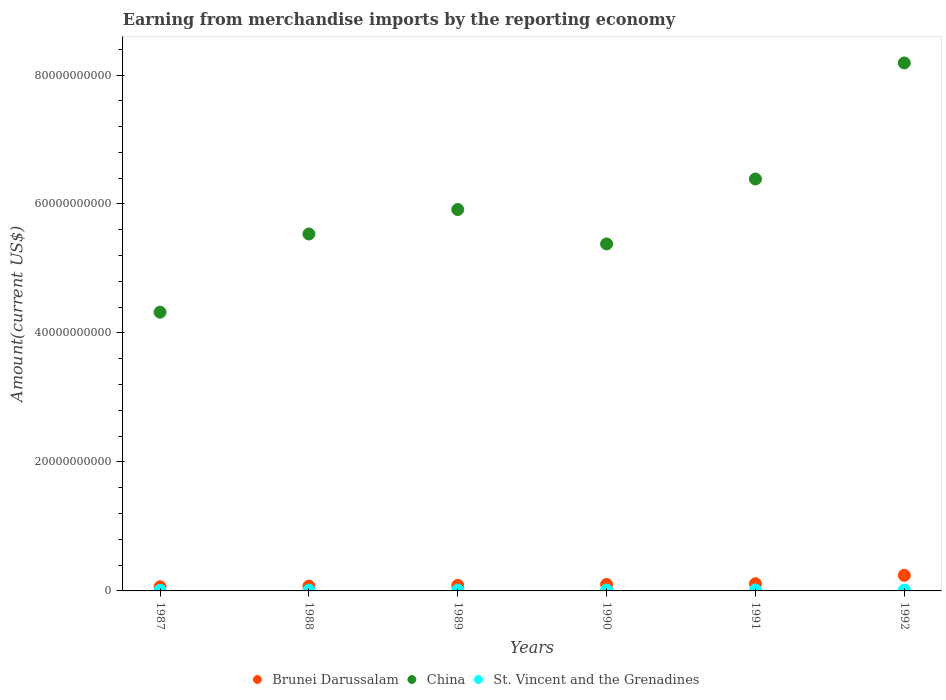Is the number of dotlines equal to the number of legend labels?
Provide a succinct answer. Yes. What is the amount earned from merchandise imports in St. Vincent and the Grenadines in 1990?
Offer a very short reply. 1.36e+08. Across all years, what is the maximum amount earned from merchandise imports in China?
Keep it short and to the point. 8.19e+1. Across all years, what is the minimum amount earned from merchandise imports in China?
Keep it short and to the point. 4.32e+1. In which year was the amount earned from merchandise imports in St. Vincent and the Grenadines minimum?
Offer a terse response. 1987. What is the total amount earned from merchandise imports in Brunei Darussalam in the graph?
Give a very brief answer. 6.77e+09. What is the difference between the amount earned from merchandise imports in St. Vincent and the Grenadines in 1988 and that in 1992?
Your answer should be compact. -2.31e+06. What is the difference between the amount earned from merchandise imports in Brunei Darussalam in 1992 and the amount earned from merchandise imports in China in 1989?
Provide a succinct answer. -5.67e+1. What is the average amount earned from merchandise imports in China per year?
Ensure brevity in your answer.  5.95e+1. In the year 1991, what is the difference between the amount earned from merchandise imports in St. Vincent and the Grenadines and amount earned from merchandise imports in China?
Make the answer very short. -6.37e+1. In how many years, is the amount earned from merchandise imports in Brunei Darussalam greater than 48000000000 US$?
Offer a very short reply. 0. What is the ratio of the amount earned from merchandise imports in St. Vincent and the Grenadines in 1990 to that in 1991?
Ensure brevity in your answer.  0.97. What is the difference between the highest and the second highest amount earned from merchandise imports in China?
Make the answer very short. 1.80e+1. What is the difference between the highest and the lowest amount earned from merchandise imports in St. Vincent and the Grenadines?
Your response must be concise. 4.17e+07. In how many years, is the amount earned from merchandise imports in St. Vincent and the Grenadines greater than the average amount earned from merchandise imports in St. Vincent and the Grenadines taken over all years?
Provide a succinct answer. 3. Is the sum of the amount earned from merchandise imports in China in 1987 and 1988 greater than the maximum amount earned from merchandise imports in St. Vincent and the Grenadines across all years?
Provide a short and direct response. Yes. Is the amount earned from merchandise imports in Brunei Darussalam strictly greater than the amount earned from merchandise imports in St. Vincent and the Grenadines over the years?
Keep it short and to the point. Yes. Is the amount earned from merchandise imports in Brunei Darussalam strictly less than the amount earned from merchandise imports in China over the years?
Your answer should be compact. Yes. Are the values on the major ticks of Y-axis written in scientific E-notation?
Offer a terse response. No. Does the graph contain any zero values?
Your answer should be compact. No. Does the graph contain grids?
Offer a terse response. No. Where does the legend appear in the graph?
Keep it short and to the point. Bottom center. What is the title of the graph?
Give a very brief answer. Earning from merchandise imports by the reporting economy. What is the label or title of the X-axis?
Provide a succinct answer. Years. What is the label or title of the Y-axis?
Offer a terse response. Amount(current US$). What is the Amount(current US$) in Brunei Darussalam in 1987?
Ensure brevity in your answer.  6.41e+08. What is the Amount(current US$) in China in 1987?
Give a very brief answer. 4.32e+1. What is the Amount(current US$) in St. Vincent and the Grenadines in 1987?
Your response must be concise. 9.80e+07. What is the Amount(current US$) of Brunei Darussalam in 1988?
Your response must be concise. 7.44e+08. What is the Amount(current US$) of China in 1988?
Offer a very short reply. 5.54e+1. What is the Amount(current US$) in St. Vincent and the Grenadines in 1988?
Give a very brief answer. 1.22e+08. What is the Amount(current US$) in Brunei Darussalam in 1989?
Offer a very short reply. 8.59e+08. What is the Amount(current US$) of China in 1989?
Provide a short and direct response. 5.91e+1. What is the Amount(current US$) in St. Vincent and the Grenadines in 1989?
Give a very brief answer. 1.27e+08. What is the Amount(current US$) of Brunei Darussalam in 1990?
Offer a terse response. 1.00e+09. What is the Amount(current US$) of China in 1990?
Provide a short and direct response. 5.38e+1. What is the Amount(current US$) of St. Vincent and the Grenadines in 1990?
Ensure brevity in your answer.  1.36e+08. What is the Amount(current US$) in Brunei Darussalam in 1991?
Make the answer very short. 1.11e+09. What is the Amount(current US$) of China in 1991?
Keep it short and to the point. 6.39e+1. What is the Amount(current US$) in St. Vincent and the Grenadines in 1991?
Give a very brief answer. 1.40e+08. What is the Amount(current US$) in Brunei Darussalam in 1992?
Keep it short and to the point. 2.42e+09. What is the Amount(current US$) of China in 1992?
Your answer should be compact. 8.19e+1. What is the Amount(current US$) in St. Vincent and the Grenadines in 1992?
Offer a very short reply. 1.25e+08. Across all years, what is the maximum Amount(current US$) in Brunei Darussalam?
Keep it short and to the point. 2.42e+09. Across all years, what is the maximum Amount(current US$) of China?
Provide a succinct answer. 8.19e+1. Across all years, what is the maximum Amount(current US$) of St. Vincent and the Grenadines?
Provide a short and direct response. 1.40e+08. Across all years, what is the minimum Amount(current US$) in Brunei Darussalam?
Keep it short and to the point. 6.41e+08. Across all years, what is the minimum Amount(current US$) of China?
Keep it short and to the point. 4.32e+1. Across all years, what is the minimum Amount(current US$) in St. Vincent and the Grenadines?
Provide a short and direct response. 9.80e+07. What is the total Amount(current US$) in Brunei Darussalam in the graph?
Ensure brevity in your answer.  6.77e+09. What is the total Amount(current US$) in China in the graph?
Offer a very short reply. 3.57e+11. What is the total Amount(current US$) in St. Vincent and the Grenadines in the graph?
Provide a succinct answer. 7.48e+08. What is the difference between the Amount(current US$) of Brunei Darussalam in 1987 and that in 1988?
Ensure brevity in your answer.  -1.03e+08. What is the difference between the Amount(current US$) of China in 1987 and that in 1988?
Make the answer very short. -1.21e+1. What is the difference between the Amount(current US$) of St. Vincent and the Grenadines in 1987 and that in 1988?
Provide a short and direct response. -2.43e+07. What is the difference between the Amount(current US$) of Brunei Darussalam in 1987 and that in 1989?
Make the answer very short. -2.18e+08. What is the difference between the Amount(current US$) in China in 1987 and that in 1989?
Ensure brevity in your answer.  -1.59e+1. What is the difference between the Amount(current US$) in St. Vincent and the Grenadines in 1987 and that in 1989?
Provide a succinct answer. -2.95e+07. What is the difference between the Amount(current US$) of Brunei Darussalam in 1987 and that in 1990?
Your answer should be very brief. -3.59e+08. What is the difference between the Amount(current US$) in China in 1987 and that in 1990?
Make the answer very short. -1.06e+1. What is the difference between the Amount(current US$) of St. Vincent and the Grenadines in 1987 and that in 1990?
Provide a short and direct response. -3.80e+07. What is the difference between the Amount(current US$) of Brunei Darussalam in 1987 and that in 1991?
Provide a short and direct response. -4.70e+08. What is the difference between the Amount(current US$) of China in 1987 and that in 1991?
Offer a terse response. -2.07e+1. What is the difference between the Amount(current US$) of St. Vincent and the Grenadines in 1987 and that in 1991?
Provide a short and direct response. -4.17e+07. What is the difference between the Amount(current US$) of Brunei Darussalam in 1987 and that in 1992?
Your answer should be compact. -1.78e+09. What is the difference between the Amount(current US$) in China in 1987 and that in 1992?
Your response must be concise. -3.86e+1. What is the difference between the Amount(current US$) in St. Vincent and the Grenadines in 1987 and that in 1992?
Offer a terse response. -2.66e+07. What is the difference between the Amount(current US$) in Brunei Darussalam in 1988 and that in 1989?
Your answer should be compact. -1.15e+08. What is the difference between the Amount(current US$) of China in 1988 and that in 1989?
Provide a succinct answer. -3.79e+09. What is the difference between the Amount(current US$) in St. Vincent and the Grenadines in 1988 and that in 1989?
Provide a succinct answer. -5.23e+06. What is the difference between the Amount(current US$) of Brunei Darussalam in 1988 and that in 1990?
Your response must be concise. -2.57e+08. What is the difference between the Amount(current US$) of China in 1988 and that in 1990?
Make the answer very short. 1.54e+09. What is the difference between the Amount(current US$) of St. Vincent and the Grenadines in 1988 and that in 1990?
Keep it short and to the point. -1.37e+07. What is the difference between the Amount(current US$) in Brunei Darussalam in 1988 and that in 1991?
Provide a succinct answer. -3.67e+08. What is the difference between the Amount(current US$) of China in 1988 and that in 1991?
Keep it short and to the point. -8.52e+09. What is the difference between the Amount(current US$) of St. Vincent and the Grenadines in 1988 and that in 1991?
Make the answer very short. -1.74e+07. What is the difference between the Amount(current US$) of Brunei Darussalam in 1988 and that in 1992?
Make the answer very short. -1.67e+09. What is the difference between the Amount(current US$) in China in 1988 and that in 1992?
Your answer should be compact. -2.65e+1. What is the difference between the Amount(current US$) of St. Vincent and the Grenadines in 1988 and that in 1992?
Provide a short and direct response. -2.31e+06. What is the difference between the Amount(current US$) of Brunei Darussalam in 1989 and that in 1990?
Give a very brief answer. -1.42e+08. What is the difference between the Amount(current US$) in China in 1989 and that in 1990?
Provide a short and direct response. 5.33e+09. What is the difference between the Amount(current US$) in St. Vincent and the Grenadines in 1989 and that in 1990?
Offer a terse response. -8.48e+06. What is the difference between the Amount(current US$) of Brunei Darussalam in 1989 and that in 1991?
Keep it short and to the point. -2.52e+08. What is the difference between the Amount(current US$) in China in 1989 and that in 1991?
Provide a short and direct response. -4.74e+09. What is the difference between the Amount(current US$) of St. Vincent and the Grenadines in 1989 and that in 1991?
Give a very brief answer. -1.22e+07. What is the difference between the Amount(current US$) in Brunei Darussalam in 1989 and that in 1992?
Keep it short and to the point. -1.56e+09. What is the difference between the Amount(current US$) of China in 1989 and that in 1992?
Keep it short and to the point. -2.27e+1. What is the difference between the Amount(current US$) in St. Vincent and the Grenadines in 1989 and that in 1992?
Your answer should be very brief. 2.92e+06. What is the difference between the Amount(current US$) in Brunei Darussalam in 1990 and that in 1991?
Your answer should be very brief. -1.11e+08. What is the difference between the Amount(current US$) in China in 1990 and that in 1991?
Your answer should be compact. -1.01e+1. What is the difference between the Amount(current US$) of St. Vincent and the Grenadines in 1990 and that in 1991?
Ensure brevity in your answer.  -3.73e+06. What is the difference between the Amount(current US$) in Brunei Darussalam in 1990 and that in 1992?
Your answer should be compact. -1.42e+09. What is the difference between the Amount(current US$) in China in 1990 and that in 1992?
Offer a very short reply. -2.81e+1. What is the difference between the Amount(current US$) in St. Vincent and the Grenadines in 1990 and that in 1992?
Provide a short and direct response. 1.14e+07. What is the difference between the Amount(current US$) in Brunei Darussalam in 1991 and that in 1992?
Ensure brevity in your answer.  -1.31e+09. What is the difference between the Amount(current US$) of China in 1991 and that in 1992?
Provide a succinct answer. -1.80e+1. What is the difference between the Amount(current US$) in St. Vincent and the Grenadines in 1991 and that in 1992?
Provide a short and direct response. 1.51e+07. What is the difference between the Amount(current US$) of Brunei Darussalam in 1987 and the Amount(current US$) of China in 1988?
Make the answer very short. -5.47e+1. What is the difference between the Amount(current US$) of Brunei Darussalam in 1987 and the Amount(current US$) of St. Vincent and the Grenadines in 1988?
Provide a succinct answer. 5.18e+08. What is the difference between the Amount(current US$) of China in 1987 and the Amount(current US$) of St. Vincent and the Grenadines in 1988?
Your answer should be compact. 4.31e+1. What is the difference between the Amount(current US$) of Brunei Darussalam in 1987 and the Amount(current US$) of China in 1989?
Your response must be concise. -5.85e+1. What is the difference between the Amount(current US$) in Brunei Darussalam in 1987 and the Amount(current US$) in St. Vincent and the Grenadines in 1989?
Your answer should be compact. 5.13e+08. What is the difference between the Amount(current US$) of China in 1987 and the Amount(current US$) of St. Vincent and the Grenadines in 1989?
Provide a short and direct response. 4.31e+1. What is the difference between the Amount(current US$) of Brunei Darussalam in 1987 and the Amount(current US$) of China in 1990?
Offer a terse response. -5.32e+1. What is the difference between the Amount(current US$) in Brunei Darussalam in 1987 and the Amount(current US$) in St. Vincent and the Grenadines in 1990?
Offer a very short reply. 5.05e+08. What is the difference between the Amount(current US$) of China in 1987 and the Amount(current US$) of St. Vincent and the Grenadines in 1990?
Offer a terse response. 4.31e+1. What is the difference between the Amount(current US$) of Brunei Darussalam in 1987 and the Amount(current US$) of China in 1991?
Your answer should be compact. -6.32e+1. What is the difference between the Amount(current US$) in Brunei Darussalam in 1987 and the Amount(current US$) in St. Vincent and the Grenadines in 1991?
Offer a very short reply. 5.01e+08. What is the difference between the Amount(current US$) in China in 1987 and the Amount(current US$) in St. Vincent and the Grenadines in 1991?
Your answer should be compact. 4.31e+1. What is the difference between the Amount(current US$) of Brunei Darussalam in 1987 and the Amount(current US$) of China in 1992?
Offer a terse response. -8.12e+1. What is the difference between the Amount(current US$) in Brunei Darussalam in 1987 and the Amount(current US$) in St. Vincent and the Grenadines in 1992?
Provide a short and direct response. 5.16e+08. What is the difference between the Amount(current US$) of China in 1987 and the Amount(current US$) of St. Vincent and the Grenadines in 1992?
Your answer should be compact. 4.31e+1. What is the difference between the Amount(current US$) in Brunei Darussalam in 1988 and the Amount(current US$) in China in 1989?
Provide a short and direct response. -5.84e+1. What is the difference between the Amount(current US$) of Brunei Darussalam in 1988 and the Amount(current US$) of St. Vincent and the Grenadines in 1989?
Keep it short and to the point. 6.16e+08. What is the difference between the Amount(current US$) in China in 1988 and the Amount(current US$) in St. Vincent and the Grenadines in 1989?
Offer a terse response. 5.52e+1. What is the difference between the Amount(current US$) of Brunei Darussalam in 1988 and the Amount(current US$) of China in 1990?
Ensure brevity in your answer.  -5.31e+1. What is the difference between the Amount(current US$) in Brunei Darussalam in 1988 and the Amount(current US$) in St. Vincent and the Grenadines in 1990?
Your response must be concise. 6.08e+08. What is the difference between the Amount(current US$) in China in 1988 and the Amount(current US$) in St. Vincent and the Grenadines in 1990?
Make the answer very short. 5.52e+1. What is the difference between the Amount(current US$) of Brunei Darussalam in 1988 and the Amount(current US$) of China in 1991?
Ensure brevity in your answer.  -6.31e+1. What is the difference between the Amount(current US$) in Brunei Darussalam in 1988 and the Amount(current US$) in St. Vincent and the Grenadines in 1991?
Your answer should be compact. 6.04e+08. What is the difference between the Amount(current US$) in China in 1988 and the Amount(current US$) in St. Vincent and the Grenadines in 1991?
Your answer should be compact. 5.52e+1. What is the difference between the Amount(current US$) of Brunei Darussalam in 1988 and the Amount(current US$) of China in 1992?
Offer a terse response. -8.11e+1. What is the difference between the Amount(current US$) in Brunei Darussalam in 1988 and the Amount(current US$) in St. Vincent and the Grenadines in 1992?
Offer a terse response. 6.19e+08. What is the difference between the Amount(current US$) of China in 1988 and the Amount(current US$) of St. Vincent and the Grenadines in 1992?
Provide a short and direct response. 5.52e+1. What is the difference between the Amount(current US$) in Brunei Darussalam in 1989 and the Amount(current US$) in China in 1990?
Make the answer very short. -5.30e+1. What is the difference between the Amount(current US$) of Brunei Darussalam in 1989 and the Amount(current US$) of St. Vincent and the Grenadines in 1990?
Your answer should be very brief. 7.23e+08. What is the difference between the Amount(current US$) in China in 1989 and the Amount(current US$) in St. Vincent and the Grenadines in 1990?
Give a very brief answer. 5.90e+1. What is the difference between the Amount(current US$) of Brunei Darussalam in 1989 and the Amount(current US$) of China in 1991?
Your answer should be very brief. -6.30e+1. What is the difference between the Amount(current US$) of Brunei Darussalam in 1989 and the Amount(current US$) of St. Vincent and the Grenadines in 1991?
Provide a short and direct response. 7.19e+08. What is the difference between the Amount(current US$) in China in 1989 and the Amount(current US$) in St. Vincent and the Grenadines in 1991?
Provide a succinct answer. 5.90e+1. What is the difference between the Amount(current US$) in Brunei Darussalam in 1989 and the Amount(current US$) in China in 1992?
Provide a succinct answer. -8.10e+1. What is the difference between the Amount(current US$) in Brunei Darussalam in 1989 and the Amount(current US$) in St. Vincent and the Grenadines in 1992?
Provide a short and direct response. 7.34e+08. What is the difference between the Amount(current US$) in China in 1989 and the Amount(current US$) in St. Vincent and the Grenadines in 1992?
Provide a short and direct response. 5.90e+1. What is the difference between the Amount(current US$) in Brunei Darussalam in 1990 and the Amount(current US$) in China in 1991?
Your response must be concise. -6.29e+1. What is the difference between the Amount(current US$) of Brunei Darussalam in 1990 and the Amount(current US$) of St. Vincent and the Grenadines in 1991?
Provide a short and direct response. 8.60e+08. What is the difference between the Amount(current US$) of China in 1990 and the Amount(current US$) of St. Vincent and the Grenadines in 1991?
Give a very brief answer. 5.37e+1. What is the difference between the Amount(current US$) in Brunei Darussalam in 1990 and the Amount(current US$) in China in 1992?
Offer a very short reply. -8.09e+1. What is the difference between the Amount(current US$) of Brunei Darussalam in 1990 and the Amount(current US$) of St. Vincent and the Grenadines in 1992?
Provide a succinct answer. 8.76e+08. What is the difference between the Amount(current US$) in China in 1990 and the Amount(current US$) in St. Vincent and the Grenadines in 1992?
Provide a succinct answer. 5.37e+1. What is the difference between the Amount(current US$) in Brunei Darussalam in 1991 and the Amount(current US$) in China in 1992?
Give a very brief answer. -8.08e+1. What is the difference between the Amount(current US$) in Brunei Darussalam in 1991 and the Amount(current US$) in St. Vincent and the Grenadines in 1992?
Provide a succinct answer. 9.86e+08. What is the difference between the Amount(current US$) of China in 1991 and the Amount(current US$) of St. Vincent and the Grenadines in 1992?
Your answer should be very brief. 6.38e+1. What is the average Amount(current US$) in Brunei Darussalam per year?
Your response must be concise. 1.13e+09. What is the average Amount(current US$) in China per year?
Make the answer very short. 5.95e+1. What is the average Amount(current US$) in St. Vincent and the Grenadines per year?
Your response must be concise. 1.25e+08. In the year 1987, what is the difference between the Amount(current US$) in Brunei Darussalam and Amount(current US$) in China?
Provide a short and direct response. -4.26e+1. In the year 1987, what is the difference between the Amount(current US$) of Brunei Darussalam and Amount(current US$) of St. Vincent and the Grenadines?
Offer a very short reply. 5.43e+08. In the year 1987, what is the difference between the Amount(current US$) in China and Amount(current US$) in St. Vincent and the Grenadines?
Your response must be concise. 4.31e+1. In the year 1988, what is the difference between the Amount(current US$) in Brunei Darussalam and Amount(current US$) in China?
Give a very brief answer. -5.46e+1. In the year 1988, what is the difference between the Amount(current US$) in Brunei Darussalam and Amount(current US$) in St. Vincent and the Grenadines?
Your answer should be compact. 6.21e+08. In the year 1988, what is the difference between the Amount(current US$) of China and Amount(current US$) of St. Vincent and the Grenadines?
Offer a very short reply. 5.52e+1. In the year 1989, what is the difference between the Amount(current US$) in Brunei Darussalam and Amount(current US$) in China?
Provide a short and direct response. -5.83e+1. In the year 1989, what is the difference between the Amount(current US$) of Brunei Darussalam and Amount(current US$) of St. Vincent and the Grenadines?
Ensure brevity in your answer.  7.31e+08. In the year 1989, what is the difference between the Amount(current US$) in China and Amount(current US$) in St. Vincent and the Grenadines?
Your response must be concise. 5.90e+1. In the year 1990, what is the difference between the Amount(current US$) of Brunei Darussalam and Amount(current US$) of China?
Provide a short and direct response. -5.28e+1. In the year 1990, what is the difference between the Amount(current US$) in Brunei Darussalam and Amount(current US$) in St. Vincent and the Grenadines?
Offer a terse response. 8.64e+08. In the year 1990, what is the difference between the Amount(current US$) in China and Amount(current US$) in St. Vincent and the Grenadines?
Your response must be concise. 5.37e+1. In the year 1991, what is the difference between the Amount(current US$) in Brunei Darussalam and Amount(current US$) in China?
Your answer should be compact. -6.28e+1. In the year 1991, what is the difference between the Amount(current US$) of Brunei Darussalam and Amount(current US$) of St. Vincent and the Grenadines?
Your answer should be compact. 9.71e+08. In the year 1991, what is the difference between the Amount(current US$) in China and Amount(current US$) in St. Vincent and the Grenadines?
Your response must be concise. 6.37e+1. In the year 1992, what is the difference between the Amount(current US$) in Brunei Darussalam and Amount(current US$) in China?
Keep it short and to the point. -7.95e+1. In the year 1992, what is the difference between the Amount(current US$) in Brunei Darussalam and Amount(current US$) in St. Vincent and the Grenadines?
Keep it short and to the point. 2.29e+09. In the year 1992, what is the difference between the Amount(current US$) in China and Amount(current US$) in St. Vincent and the Grenadines?
Ensure brevity in your answer.  8.17e+1. What is the ratio of the Amount(current US$) in Brunei Darussalam in 1987 to that in 1988?
Offer a very short reply. 0.86. What is the ratio of the Amount(current US$) of China in 1987 to that in 1988?
Your answer should be compact. 0.78. What is the ratio of the Amount(current US$) in St. Vincent and the Grenadines in 1987 to that in 1988?
Offer a terse response. 0.8. What is the ratio of the Amount(current US$) of Brunei Darussalam in 1987 to that in 1989?
Keep it short and to the point. 0.75. What is the ratio of the Amount(current US$) of China in 1987 to that in 1989?
Your answer should be compact. 0.73. What is the ratio of the Amount(current US$) in St. Vincent and the Grenadines in 1987 to that in 1989?
Offer a terse response. 0.77. What is the ratio of the Amount(current US$) in Brunei Darussalam in 1987 to that in 1990?
Your answer should be compact. 0.64. What is the ratio of the Amount(current US$) in China in 1987 to that in 1990?
Offer a very short reply. 0.8. What is the ratio of the Amount(current US$) of St. Vincent and the Grenadines in 1987 to that in 1990?
Provide a short and direct response. 0.72. What is the ratio of the Amount(current US$) in Brunei Darussalam in 1987 to that in 1991?
Give a very brief answer. 0.58. What is the ratio of the Amount(current US$) of China in 1987 to that in 1991?
Keep it short and to the point. 0.68. What is the ratio of the Amount(current US$) of St. Vincent and the Grenadines in 1987 to that in 1991?
Your response must be concise. 0.7. What is the ratio of the Amount(current US$) of Brunei Darussalam in 1987 to that in 1992?
Ensure brevity in your answer.  0.27. What is the ratio of the Amount(current US$) of China in 1987 to that in 1992?
Make the answer very short. 0.53. What is the ratio of the Amount(current US$) of St. Vincent and the Grenadines in 1987 to that in 1992?
Offer a terse response. 0.79. What is the ratio of the Amount(current US$) of Brunei Darussalam in 1988 to that in 1989?
Give a very brief answer. 0.87. What is the ratio of the Amount(current US$) in China in 1988 to that in 1989?
Give a very brief answer. 0.94. What is the ratio of the Amount(current US$) of St. Vincent and the Grenadines in 1988 to that in 1989?
Your answer should be compact. 0.96. What is the ratio of the Amount(current US$) of Brunei Darussalam in 1988 to that in 1990?
Your response must be concise. 0.74. What is the ratio of the Amount(current US$) in China in 1988 to that in 1990?
Ensure brevity in your answer.  1.03. What is the ratio of the Amount(current US$) of St. Vincent and the Grenadines in 1988 to that in 1990?
Your response must be concise. 0.9. What is the ratio of the Amount(current US$) of Brunei Darussalam in 1988 to that in 1991?
Your response must be concise. 0.67. What is the ratio of the Amount(current US$) in China in 1988 to that in 1991?
Make the answer very short. 0.87. What is the ratio of the Amount(current US$) in St. Vincent and the Grenadines in 1988 to that in 1991?
Ensure brevity in your answer.  0.88. What is the ratio of the Amount(current US$) of Brunei Darussalam in 1988 to that in 1992?
Your answer should be compact. 0.31. What is the ratio of the Amount(current US$) in China in 1988 to that in 1992?
Your response must be concise. 0.68. What is the ratio of the Amount(current US$) of St. Vincent and the Grenadines in 1988 to that in 1992?
Make the answer very short. 0.98. What is the ratio of the Amount(current US$) in Brunei Darussalam in 1989 to that in 1990?
Provide a short and direct response. 0.86. What is the ratio of the Amount(current US$) of China in 1989 to that in 1990?
Provide a short and direct response. 1.1. What is the ratio of the Amount(current US$) in St. Vincent and the Grenadines in 1989 to that in 1990?
Your answer should be compact. 0.94. What is the ratio of the Amount(current US$) of Brunei Darussalam in 1989 to that in 1991?
Your answer should be compact. 0.77. What is the ratio of the Amount(current US$) of China in 1989 to that in 1991?
Provide a succinct answer. 0.93. What is the ratio of the Amount(current US$) in St. Vincent and the Grenadines in 1989 to that in 1991?
Provide a short and direct response. 0.91. What is the ratio of the Amount(current US$) of Brunei Darussalam in 1989 to that in 1992?
Ensure brevity in your answer.  0.36. What is the ratio of the Amount(current US$) of China in 1989 to that in 1992?
Offer a very short reply. 0.72. What is the ratio of the Amount(current US$) of St. Vincent and the Grenadines in 1989 to that in 1992?
Your answer should be compact. 1.02. What is the ratio of the Amount(current US$) in Brunei Darussalam in 1990 to that in 1991?
Offer a terse response. 0.9. What is the ratio of the Amount(current US$) in China in 1990 to that in 1991?
Ensure brevity in your answer.  0.84. What is the ratio of the Amount(current US$) in St. Vincent and the Grenadines in 1990 to that in 1991?
Give a very brief answer. 0.97. What is the ratio of the Amount(current US$) of Brunei Darussalam in 1990 to that in 1992?
Offer a terse response. 0.41. What is the ratio of the Amount(current US$) of China in 1990 to that in 1992?
Make the answer very short. 0.66. What is the ratio of the Amount(current US$) of St. Vincent and the Grenadines in 1990 to that in 1992?
Your answer should be compact. 1.09. What is the ratio of the Amount(current US$) of Brunei Darussalam in 1991 to that in 1992?
Your answer should be compact. 0.46. What is the ratio of the Amount(current US$) of China in 1991 to that in 1992?
Provide a short and direct response. 0.78. What is the ratio of the Amount(current US$) in St. Vincent and the Grenadines in 1991 to that in 1992?
Your answer should be very brief. 1.12. What is the difference between the highest and the second highest Amount(current US$) in Brunei Darussalam?
Keep it short and to the point. 1.31e+09. What is the difference between the highest and the second highest Amount(current US$) in China?
Your answer should be compact. 1.80e+1. What is the difference between the highest and the second highest Amount(current US$) of St. Vincent and the Grenadines?
Give a very brief answer. 3.73e+06. What is the difference between the highest and the lowest Amount(current US$) of Brunei Darussalam?
Provide a succinct answer. 1.78e+09. What is the difference between the highest and the lowest Amount(current US$) in China?
Provide a succinct answer. 3.86e+1. What is the difference between the highest and the lowest Amount(current US$) of St. Vincent and the Grenadines?
Provide a succinct answer. 4.17e+07. 